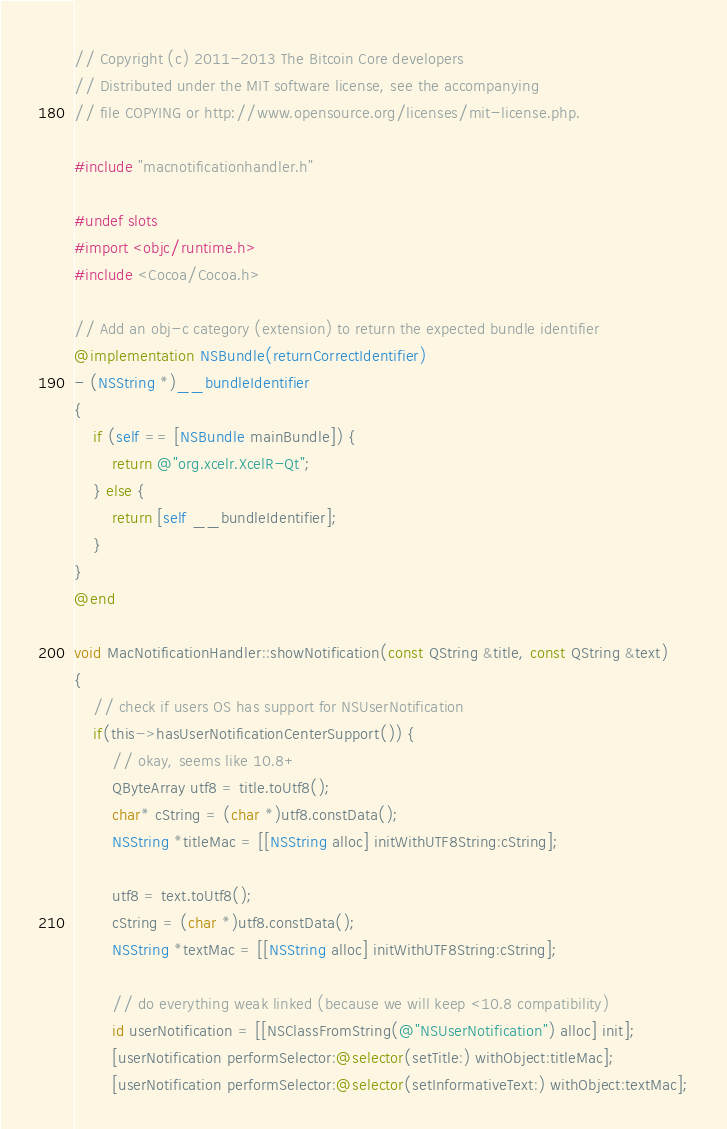Convert code to text. <code><loc_0><loc_0><loc_500><loc_500><_ObjectiveC_>// Copyright (c) 2011-2013 The Bitcoin Core developers
// Distributed under the MIT software license, see the accompanying
// file COPYING or http://www.opensource.org/licenses/mit-license.php.

#include "macnotificationhandler.h"

#undef slots
#import <objc/runtime.h>
#include <Cocoa/Cocoa.h>

// Add an obj-c category (extension) to return the expected bundle identifier
@implementation NSBundle(returnCorrectIdentifier)
- (NSString *)__bundleIdentifier
{
    if (self == [NSBundle mainBundle]) {
        return @"org.xcelr.XcelR-Qt";
    } else {
        return [self __bundleIdentifier];
    }
}
@end

void MacNotificationHandler::showNotification(const QString &title, const QString &text)
{
    // check if users OS has support for NSUserNotification
    if(this->hasUserNotificationCenterSupport()) {
        // okay, seems like 10.8+
        QByteArray utf8 = title.toUtf8();
        char* cString = (char *)utf8.constData();
        NSString *titleMac = [[NSString alloc] initWithUTF8String:cString];

        utf8 = text.toUtf8();
        cString = (char *)utf8.constData();
        NSString *textMac = [[NSString alloc] initWithUTF8String:cString];

        // do everything weak linked (because we will keep <10.8 compatibility)
        id userNotification = [[NSClassFromString(@"NSUserNotification") alloc] init];
        [userNotification performSelector:@selector(setTitle:) withObject:titleMac];
        [userNotification performSelector:@selector(setInformativeText:) withObject:textMac];
</code> 